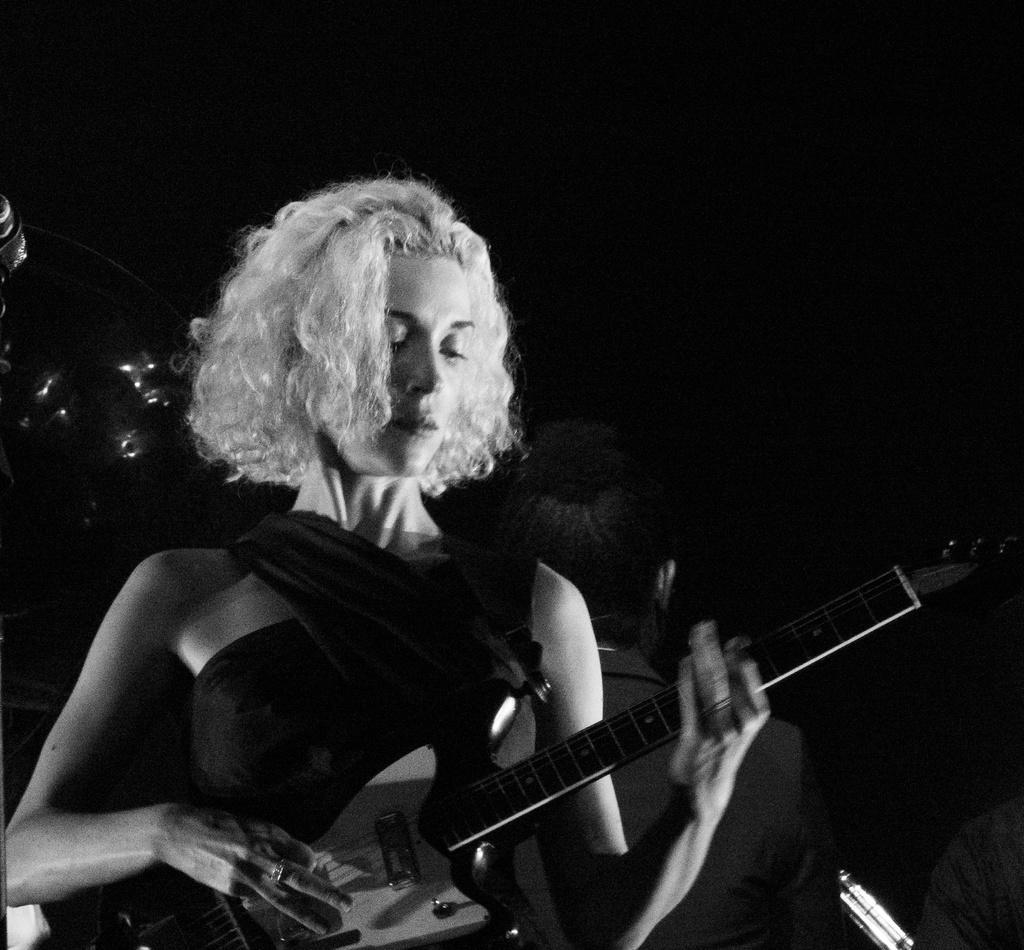Could you give a brief overview of what you see in this image? It is a black and white picture of a woman holding a guitar. In the background there are some persons. 